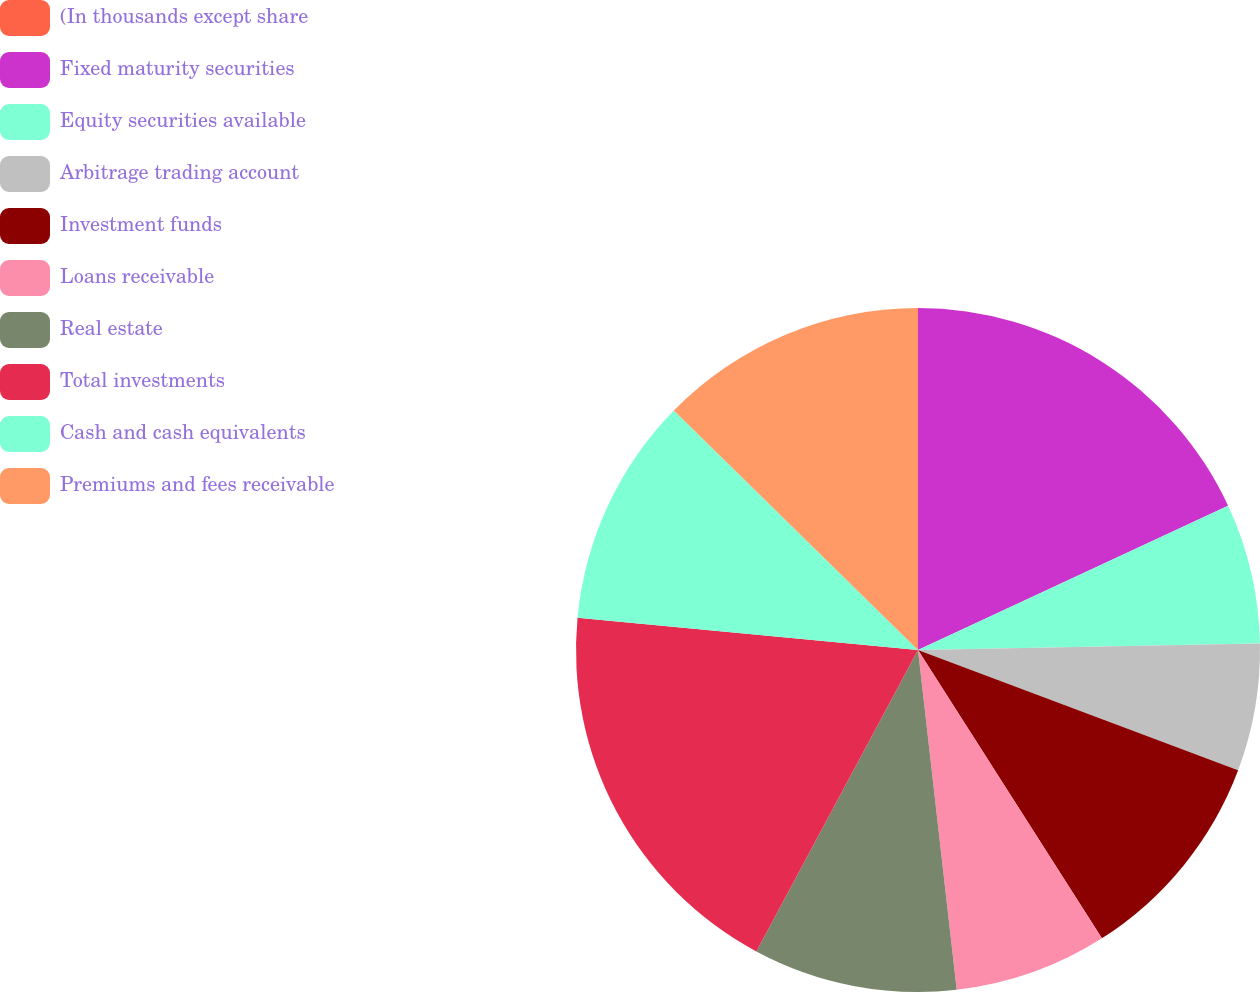<chart> <loc_0><loc_0><loc_500><loc_500><pie_chart><fcel>(In thousands except share<fcel>Fixed maturity securities<fcel>Equity securities available<fcel>Arbitrage trading account<fcel>Investment funds<fcel>Loans receivable<fcel>Real estate<fcel>Total investments<fcel>Cash and cash equivalents<fcel>Premiums and fees receivable<nl><fcel>0.0%<fcel>18.07%<fcel>6.63%<fcel>6.02%<fcel>10.24%<fcel>7.23%<fcel>9.64%<fcel>18.67%<fcel>10.84%<fcel>12.65%<nl></chart> 